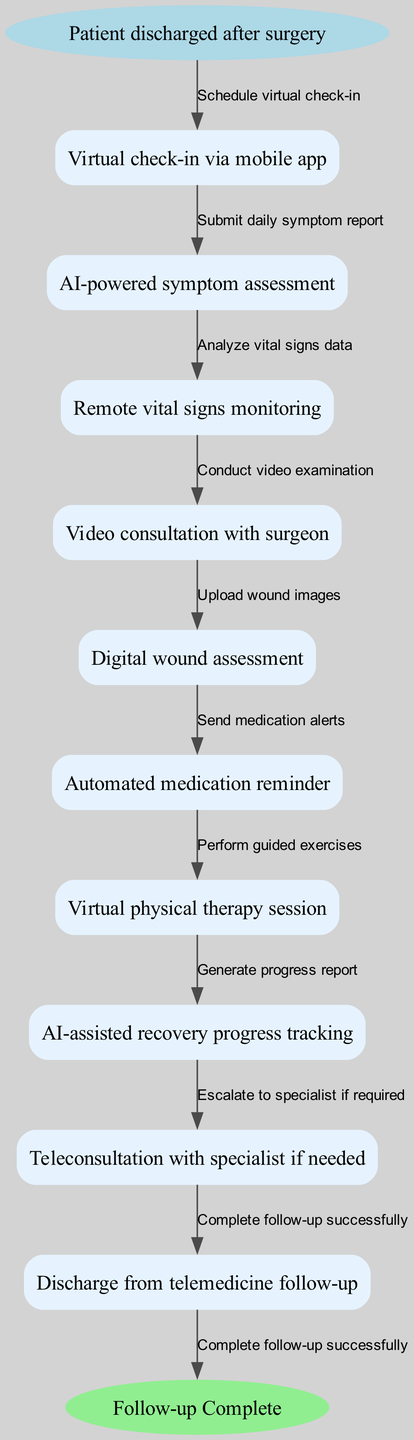What is the starting point of the pathway? The starting point, as per the diagram, is the node labeled "Patient discharged after surgery."
Answer: Patient discharged after surgery How many nodes are there in total? The diagram lists a start node, 9 additional nodes representing various follow-up steps, and an end node, totaling 11 nodes.
Answer: 11 What is the last step before discharge? The last step before discharge is represented by the node "Teleconsultation with specialist if needed."
Answer: Teleconsultation with specialist if needed Which step comes immediately after virtual check-in via mobile app? The step that follows "Virtual check-in via mobile app" is "AI-powered symptom assessment," according to the diagram's flow.
Answer: AI-powered symptom assessment How many edges are in the pathway? There is one edge connecting the start node to the first node, followed by edges connecting each subsequent node, leading to a total of 10 edges in the pathway.
Answer: 10 What action is taken during the video consultation with the surgeon? During the "Video consultation with surgeon," a "Conduct video examination" action is performed as mentioned in the edge connecting these two nodes.
Answer: Conduct video examination Which node involves tracking recovery progress? The node that involves tracking recovery progress is labeled "AI-assisted recovery progress tracking."
Answer: AI-assisted recovery progress tracking What is the role of the automated medication reminder? The automated medication reminder's role is to "Send medication alerts" to ensure patients take their medications on schedule, as indicated in the respective edge.
Answer: Send medication alerts How does the pathway escalate care if needed? Care is escalated through the step "Teleconsultation with specialist if needed," which allows for specialist involvement based on the patient's conditions or needs.
Answer: Teleconsultation with specialist if needed 